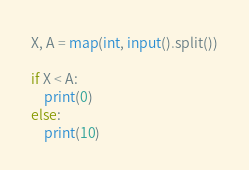<code> <loc_0><loc_0><loc_500><loc_500><_Python_>X, A = map(int, input().split())

if X < A:
    print(0)
else:
    print(10)</code> 